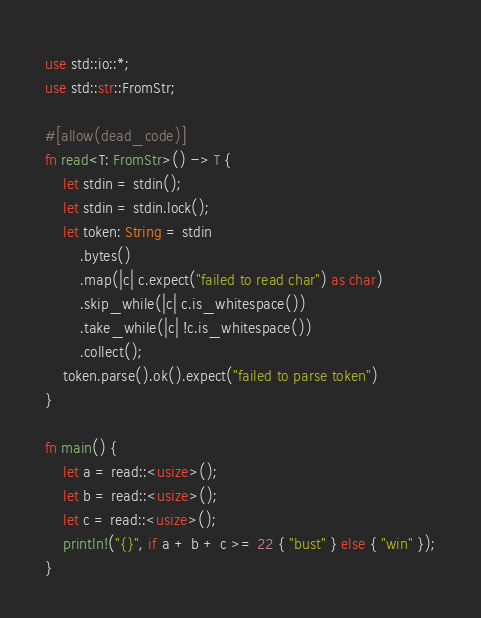Convert code to text. <code><loc_0><loc_0><loc_500><loc_500><_Rust_>use std::io::*;
use std::str::FromStr;

#[allow(dead_code)]
fn read<T: FromStr>() -> T {
    let stdin = stdin();
    let stdin = stdin.lock();
    let token: String = stdin
        .bytes()
        .map(|c| c.expect("failed to read char") as char)
        .skip_while(|c| c.is_whitespace())
        .take_while(|c| !c.is_whitespace())
        .collect();
    token.parse().ok().expect("failed to parse token")
}

fn main() {
    let a = read::<usize>();
    let b = read::<usize>();
    let c = read::<usize>();
    println!("{}", if a + b + c >= 22 { "bust" } else { "win" });
}
</code> 